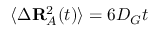Convert formula to latex. <formula><loc_0><loc_0><loc_500><loc_500>\langle \Delta R _ { A } ^ { 2 } ( t ) \rangle = 6 D _ { G } t</formula> 